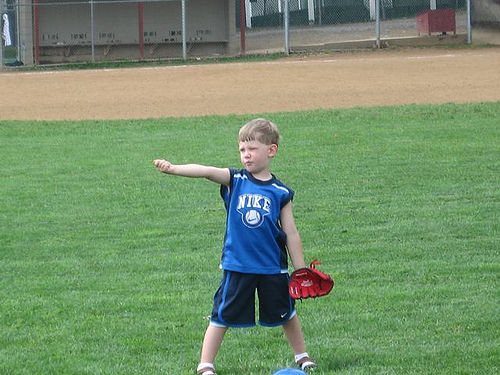Please provide a short description for this region: [0.44, 0.47, 0.58, 0.67]. The specified area includes a vibrant part of the boy’s attire, featuring his blue shirt which is neatly tucked in and gives him a sporty look while he plays. 